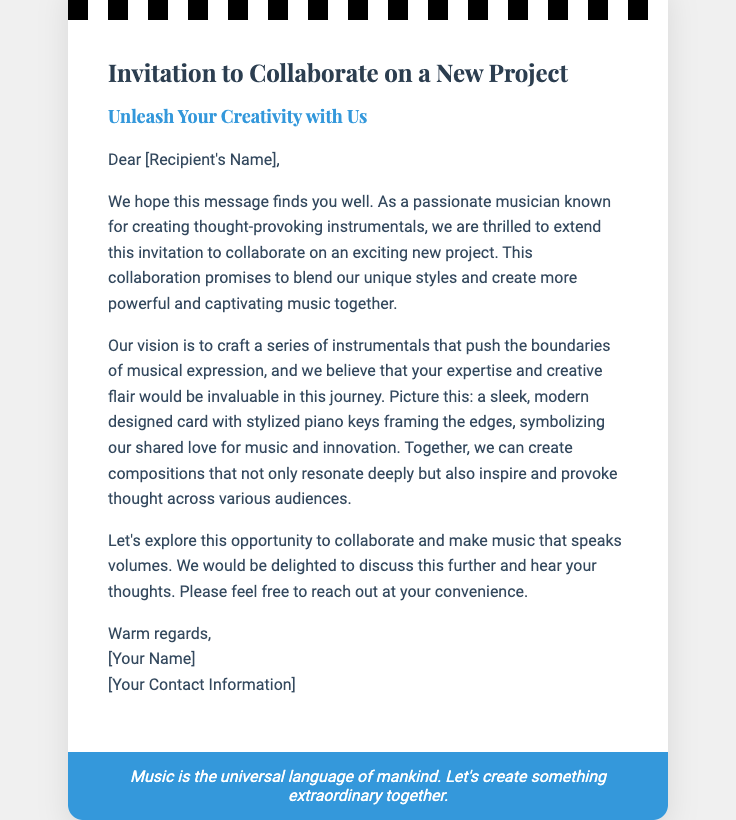What is the title of the card? The title of the card is prominently displayed at the top of the content section.
Answer: Invitation to Collaborate on a New Project Who is the card addressed to? The card is personalized for an individual, indicated in the greeting.
Answer: [Recipient's Name] What color is the footer background? The footer background color is specified in the styling of the card.
Answer: #3498db What type of music does the invitation focus on? The document emphasizes a specific genre of music in terms of creativity.
Answer: Instrumentals What does the card invite the recipient to do? The primary purpose of the card is highlighted in the opening lines.
Answer: Collaborate on a New Project Why is collaboration emphasized in the document? The document discusses the benefits of joining creative forces for a shared endeavor.
Answer: Create more powerful and captivating music together What is mentioned as a symbol of shared love? The document includes a visual representation related to music.
Answer: Stylized piano keys What sentiment is expressed towards the end of the card? The closing part of the card conveys a common theme about music and creation.
Answer: Extraordinary together What does the document describe at the beginning? The introduction sets the stage for what the recipient can expect in the project.
Answer: An exciting new project What kind of style does the card have? The design aspect of the card is reflective of its modern aesthetic.
Answer: Sleek, modern designed card 